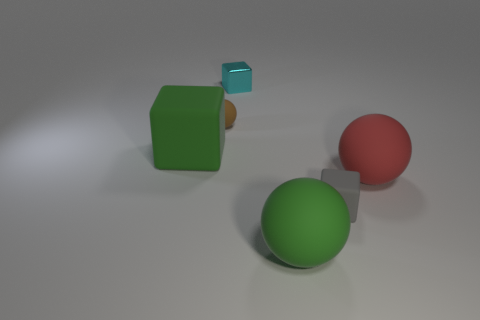There is a sphere that is the same color as the big rubber cube; what material is it?
Your answer should be compact. Rubber. How many large green things have the same shape as the small cyan metal thing?
Offer a terse response. 1. Is the color of the thing that is on the left side of the brown matte object the same as the big matte sphere that is in front of the big red matte thing?
Make the answer very short. Yes. There is a cyan object that is the same size as the brown thing; what is its material?
Keep it short and to the point. Metal. Are there any green rubber objects that have the same size as the green matte cube?
Your answer should be very brief. Yes. Is the number of green things that are on the left side of the brown matte sphere less than the number of tiny cyan metal objects?
Make the answer very short. No. Are there fewer cyan metal things that are to the left of the small cyan metal block than green matte things to the left of the green rubber ball?
Provide a succinct answer. Yes. What number of blocks are brown objects or gray objects?
Your answer should be very brief. 1. Is the large sphere that is behind the green sphere made of the same material as the big thing to the left of the small matte sphere?
Offer a terse response. Yes. What is the shape of the metal object that is the same size as the gray matte cube?
Provide a succinct answer. Cube. 